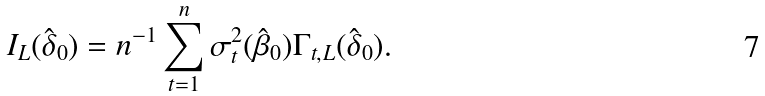<formula> <loc_0><loc_0><loc_500><loc_500>I _ { L } ( \hat { \delta } _ { 0 } ) = n ^ { - 1 } \sum _ { t = 1 } ^ { n } \sigma _ { t } ^ { 2 } ( \hat { \beta } _ { 0 } ) \Gamma _ { t , L } ( \hat { \delta } _ { 0 } ) .</formula> 